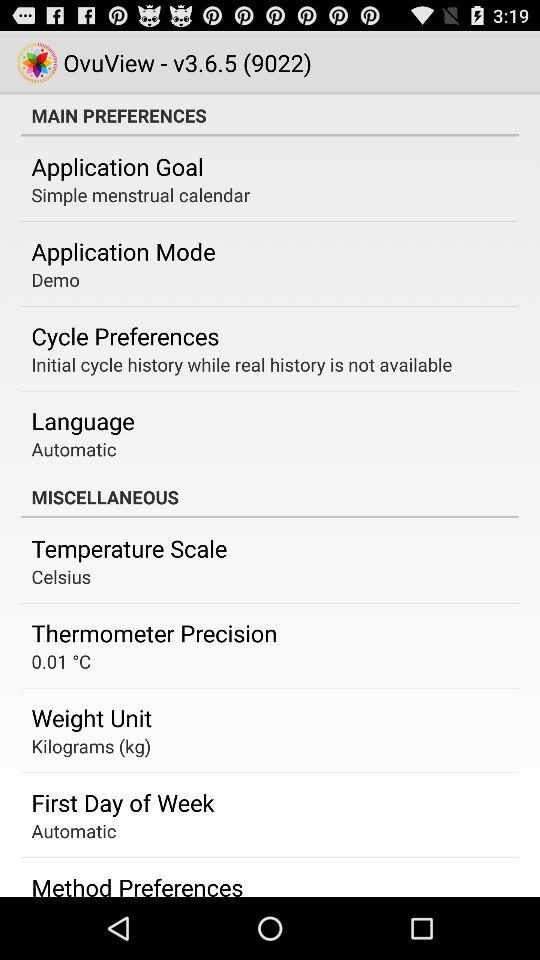What is the unit of weight? The unit of weight is kilograms (kg). 